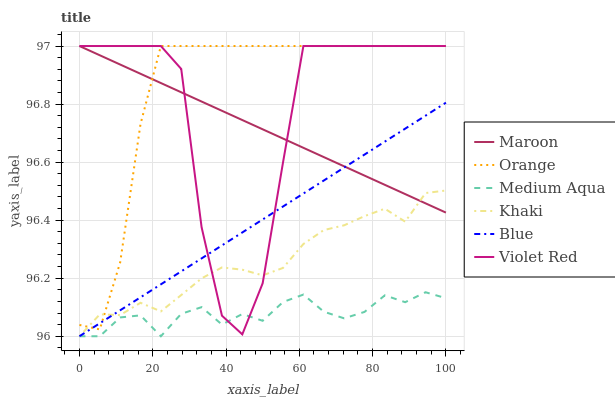Does Medium Aqua have the minimum area under the curve?
Answer yes or no. Yes. Does Orange have the maximum area under the curve?
Answer yes or no. Yes. Does Violet Red have the minimum area under the curve?
Answer yes or no. No. Does Violet Red have the maximum area under the curve?
Answer yes or no. No. Is Blue the smoothest?
Answer yes or no. Yes. Is Violet Red the roughest?
Answer yes or no. Yes. Is Khaki the smoothest?
Answer yes or no. No. Is Khaki the roughest?
Answer yes or no. No. Does Blue have the lowest value?
Answer yes or no. Yes. Does Violet Red have the lowest value?
Answer yes or no. No. Does Orange have the highest value?
Answer yes or no. Yes. Does Khaki have the highest value?
Answer yes or no. No. Is Medium Aqua less than Maroon?
Answer yes or no. Yes. Is Orange greater than Medium Aqua?
Answer yes or no. Yes. Does Orange intersect Khaki?
Answer yes or no. Yes. Is Orange less than Khaki?
Answer yes or no. No. Is Orange greater than Khaki?
Answer yes or no. No. Does Medium Aqua intersect Maroon?
Answer yes or no. No. 